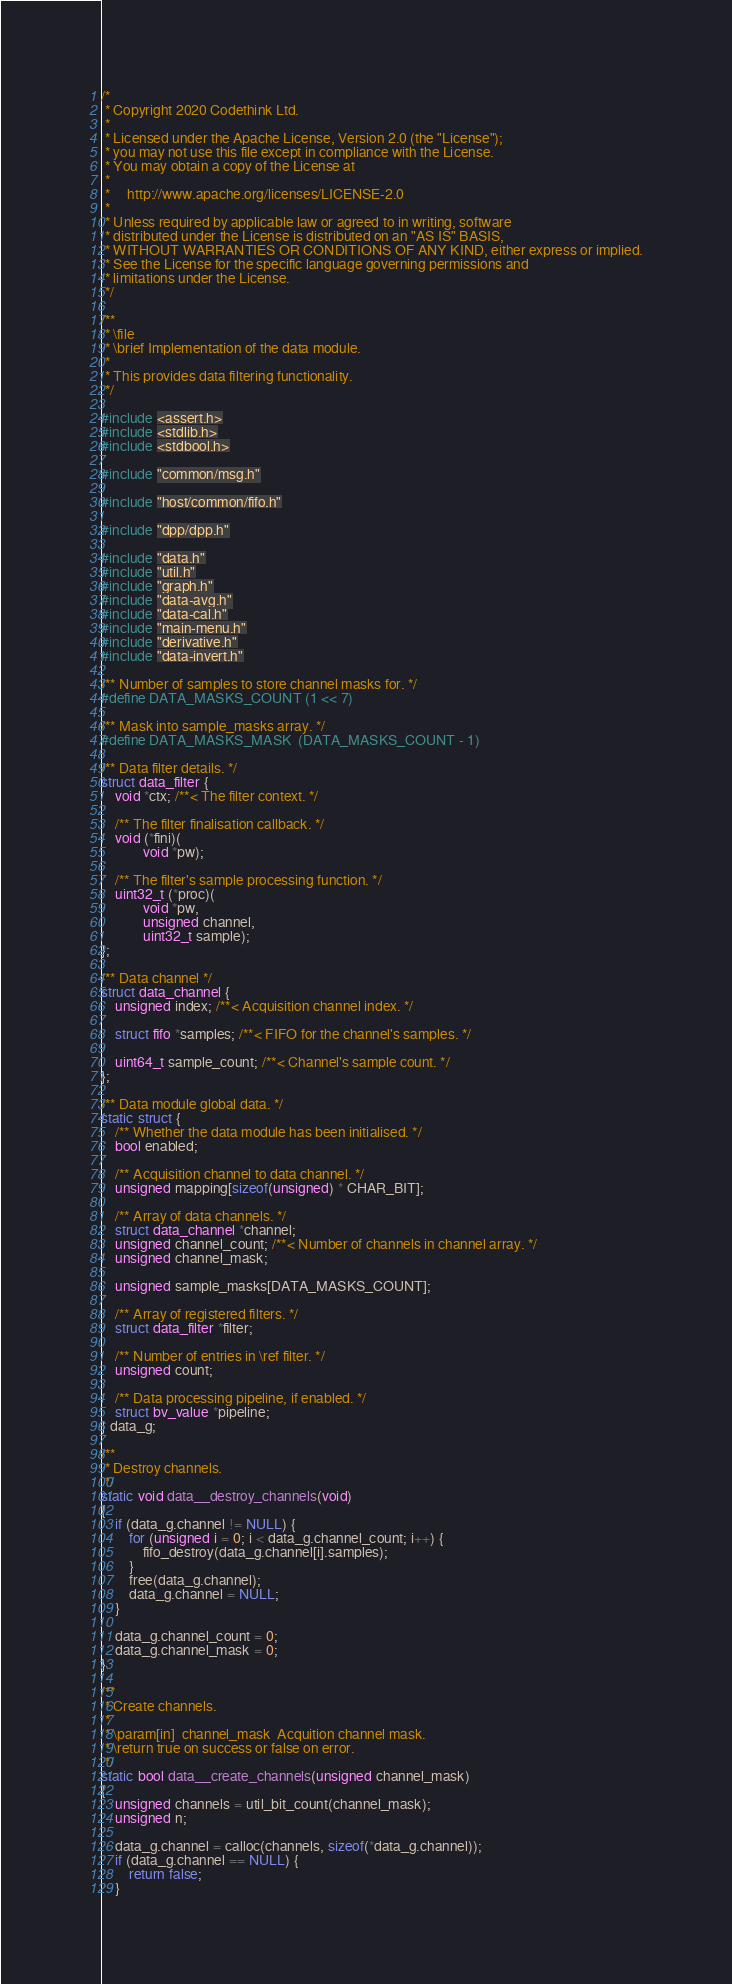<code> <loc_0><loc_0><loc_500><loc_500><_C_>/*
 * Copyright 2020 Codethink Ltd.
 *
 * Licensed under the Apache License, Version 2.0 (the "License");
 * you may not use this file except in compliance with the License.
 * You may obtain a copy of the License at
 *
 *     http://www.apache.org/licenses/LICENSE-2.0
 *
 * Unless required by applicable law or agreed to in writing, software
 * distributed under the License is distributed on an "AS IS" BASIS,
 * WITHOUT WARRANTIES OR CONDITIONS OF ANY KIND, either express or implied.
 * See the License for the specific language governing permissions and
 * limitations under the License.
 */

/**
 * \file
 * \brief Implementation of the data module.
 *
 * This provides data filtering functionality.
 */

#include <assert.h>
#include <stdlib.h>
#include <stdbool.h>

#include "common/msg.h"

#include "host/common/fifo.h"

#include "dpp/dpp.h"

#include "data.h"
#include "util.h"
#include "graph.h"
#include "data-avg.h"
#include "data-cal.h"
#include "main-menu.h"
#include "derivative.h"
#include "data-invert.h"

/** Number of samples to store channel masks for. */
#define DATA_MASKS_COUNT (1 << 7)

/** Mask into sample_masks array. */
#define DATA_MASKS_MASK  (DATA_MASKS_COUNT - 1)

/** Data filter details. */
struct data_filter {
	void *ctx; /**< The filter context. */

	/** The filter finalisation callback. */
	void (*fini)(
			void *pw);

	/** The filter's sample processing function. */
	uint32_t (*proc)(
			void *pw,
			unsigned channel,
			uint32_t sample);
};

/** Data channel */
struct data_channel {
	unsigned index; /**< Acquisition channel index. */

	struct fifo *samples; /**< FIFO for the channel's samples. */

	uint64_t sample_count; /**< Channel's sample count. */
};

/** Data module global data. */
static struct {
	/** Whether the data module has been initialised. */
	bool enabled;

	/** Acquisition channel to data channel. */
	unsigned mapping[sizeof(unsigned) * CHAR_BIT];

	/** Array of data channels. */
	struct data_channel *channel;
	unsigned channel_count; /**< Number of channels in channel array. */
	unsigned channel_mask;

	unsigned sample_masks[DATA_MASKS_COUNT];

	/** Array of registered filters. */
	struct data_filter *filter;

	/** Number of entries in \ref filter. */
	unsigned count;

	/** Data processing pipeline, if enabled. */
	struct bv_value *pipeline;
} data_g;

/**
 * Destroy channels.
 */
static void data__destroy_channels(void)
{
	if (data_g.channel != NULL) {
		for (unsigned i = 0; i < data_g.channel_count; i++) {
			fifo_destroy(data_g.channel[i].samples);
		}
		free(data_g.channel);
		data_g.channel = NULL;
	}

	data_g.channel_count = 0;
	data_g.channel_mask = 0;
}

/**
 * Create channels.
 *
 * \param[in]  channel_mask  Acquition channel mask.
 * \return true on success or false on error.
 */
static bool data__create_channels(unsigned channel_mask)
{
	unsigned channels = util_bit_count(channel_mask);
	unsigned n;

	data_g.channel = calloc(channels, sizeof(*data_g.channel));
	if (data_g.channel == NULL) {
		return false;
	}</code> 